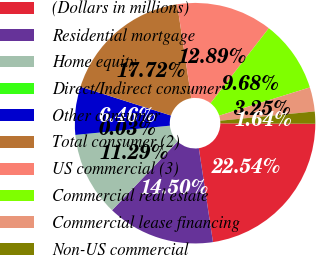Convert chart. <chart><loc_0><loc_0><loc_500><loc_500><pie_chart><fcel>(Dollars in millions)<fcel>Residential mortgage<fcel>Home equity<fcel>Direct/Indirect consumer<fcel>Other consumer<fcel>Total consumer (2)<fcel>US commercial (3)<fcel>Commercial real estate<fcel>Commercial lease financing<fcel>Non-US commercial<nl><fcel>22.54%<fcel>14.5%<fcel>11.29%<fcel>0.03%<fcel>6.46%<fcel>17.72%<fcel>12.89%<fcel>9.68%<fcel>3.25%<fcel>1.64%<nl></chart> 